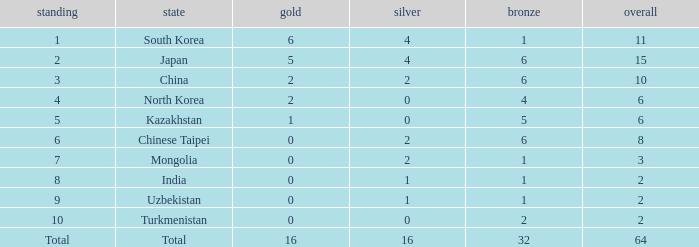How many Golds did Rank 10 get, with a Bronze larger than 2? 0.0. 